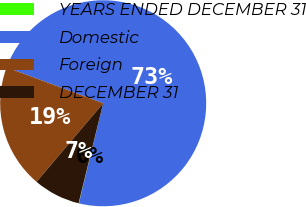Convert chart. <chart><loc_0><loc_0><loc_500><loc_500><pie_chart><fcel>YEARS ENDED DECEMBER 31<fcel>Domestic<fcel>Foreign<fcel>DECEMBER 31<nl><fcel>0.05%<fcel>73.13%<fcel>19.47%<fcel>7.35%<nl></chart> 